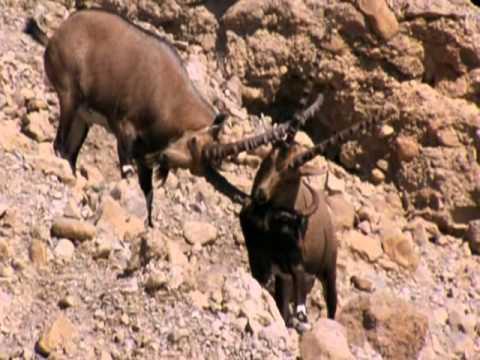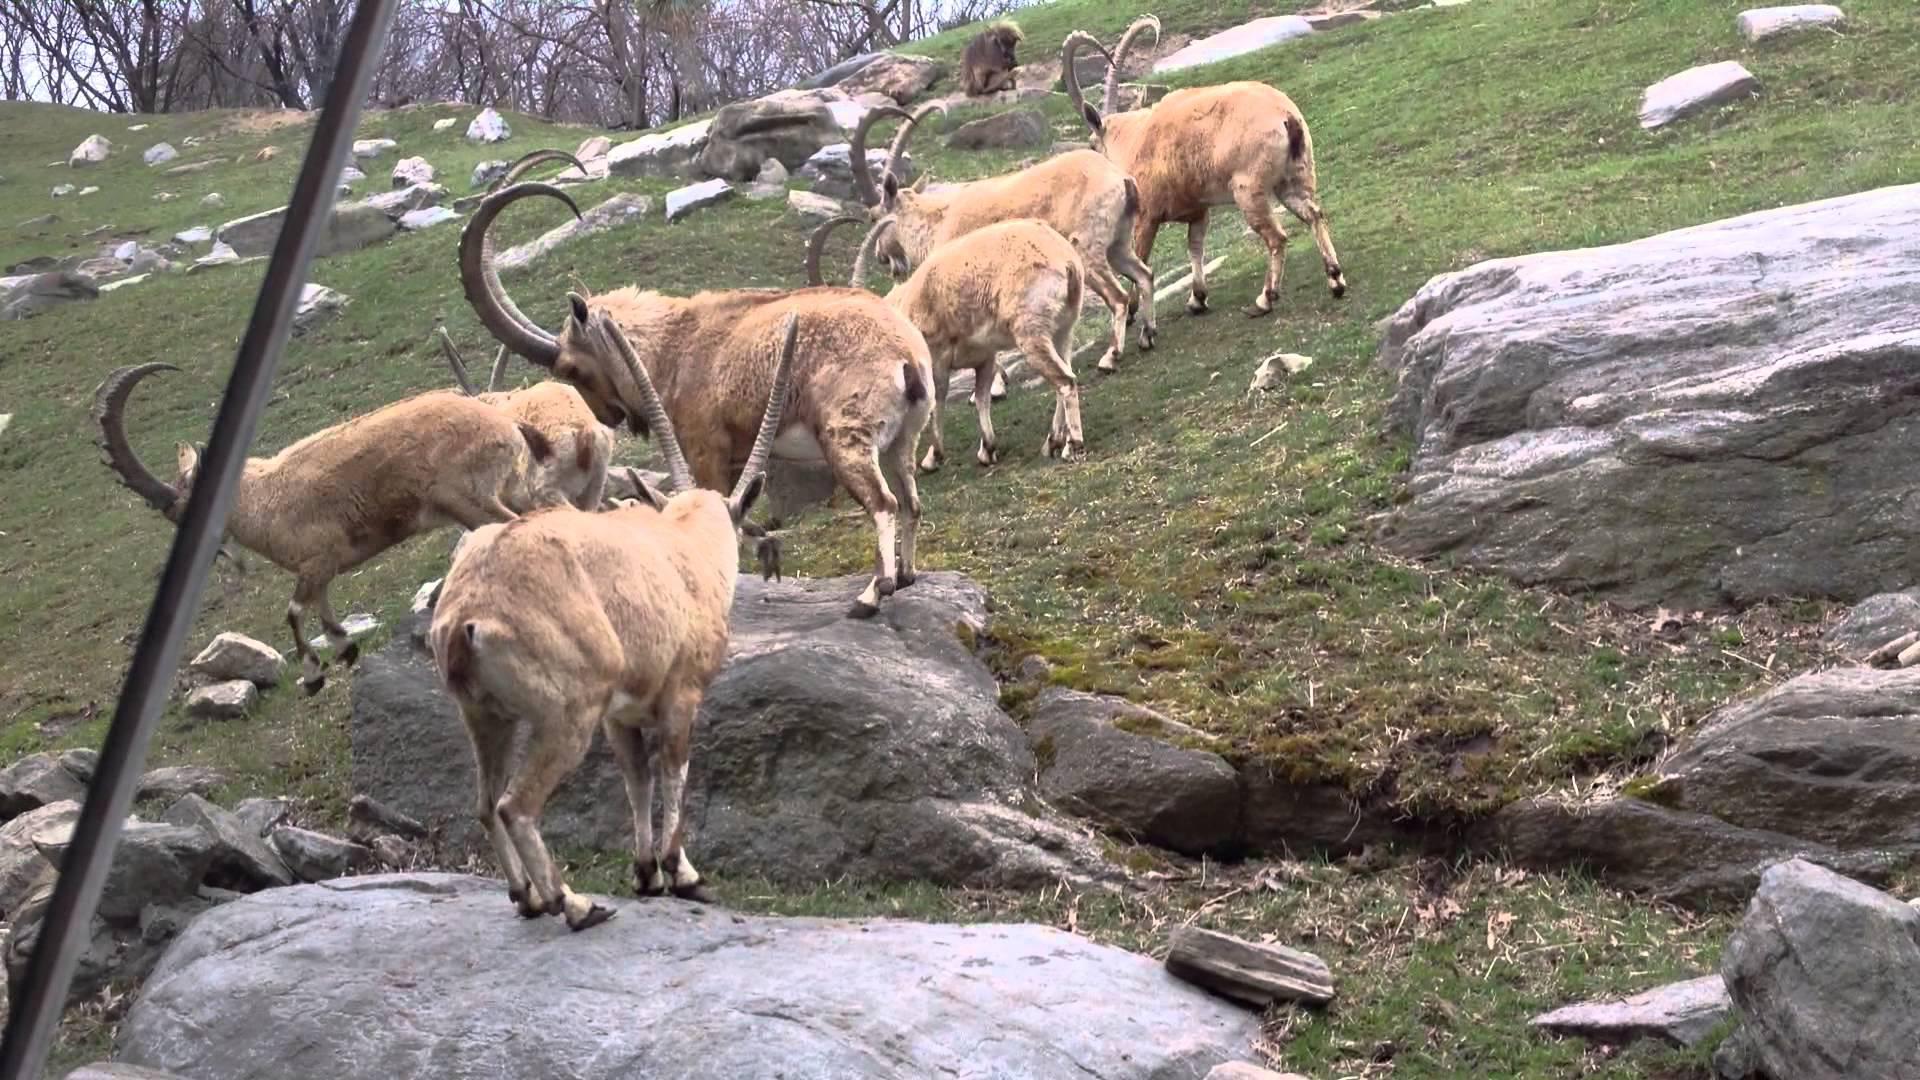The first image is the image on the left, the second image is the image on the right. Given the left and right images, does the statement "An image includes a rearing horned animal, with both its front legs high off the ground." hold true? Answer yes or no. No. The first image is the image on the left, the second image is the image on the right. Assess this claim about the two images: "Two animals are butting heads in the image on the right.". Correct or not? Answer yes or no. No. 